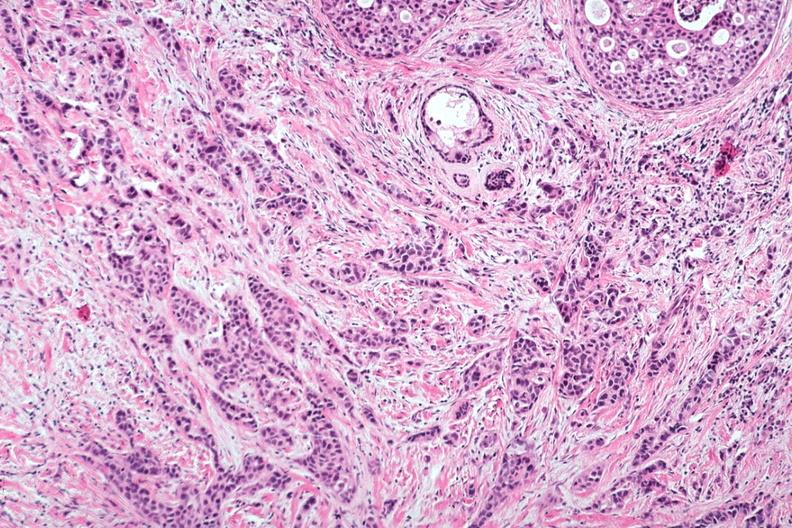where is this area in the body?
Answer the question using a single word or phrase. Breast 